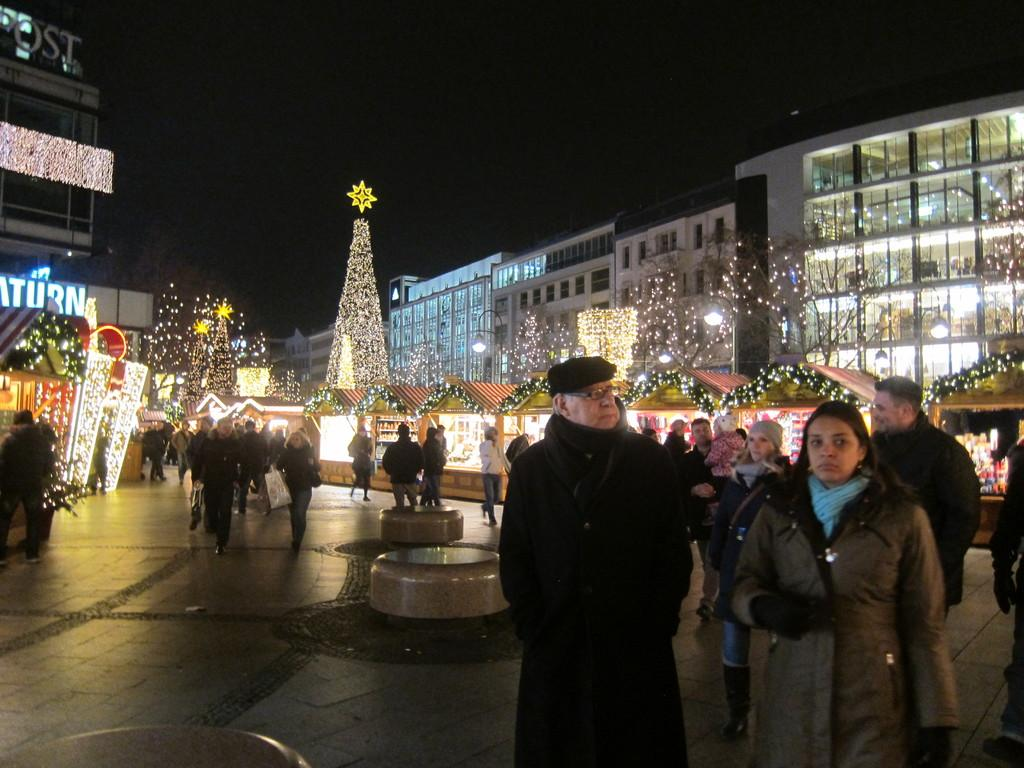What are the people in the image doing? The group of people is standing on the ground. What type of seating is present in the image? There are benches in the image. What type of structures can be seen in the image? There are buildings with windows and houses with roofs in the image. What is unique about the trees in the image? The trees are decorated with lights in the image. What letters are being displayed on the clam in the image? There is no clam present in the image, and therefore no letters can be displayed on it. 